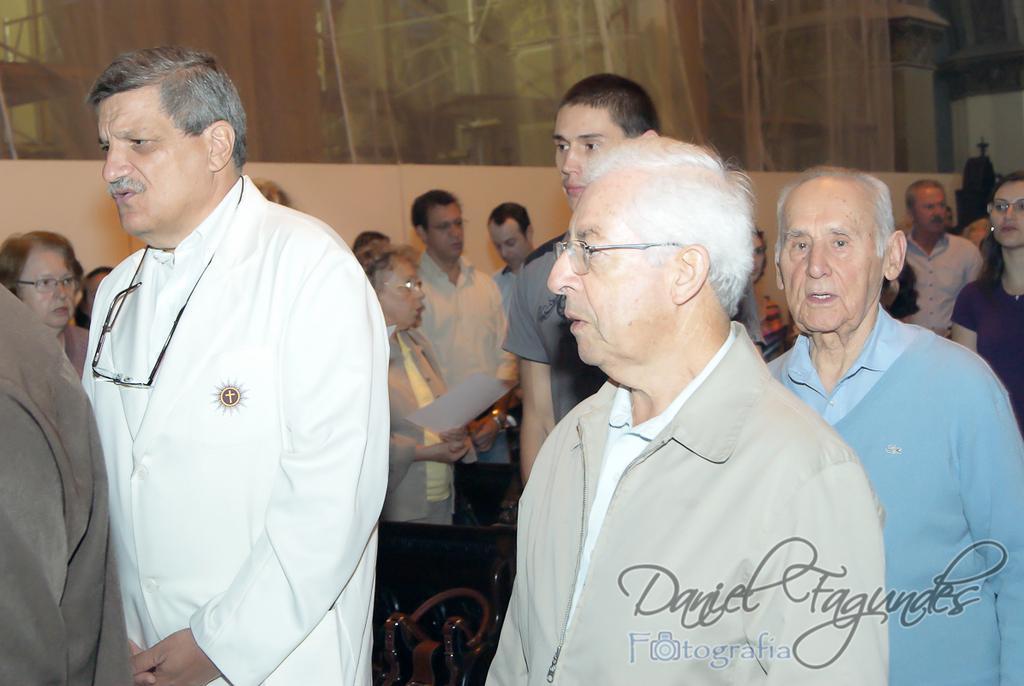How would you summarize this image in a sentence or two? In this image we can see many people. A person is holding a paper in the image. There is an object at the bottom of the image. There is some watermark at the rightmost bottom of the image. 